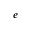<formula> <loc_0><loc_0><loc_500><loc_500>e</formula> 